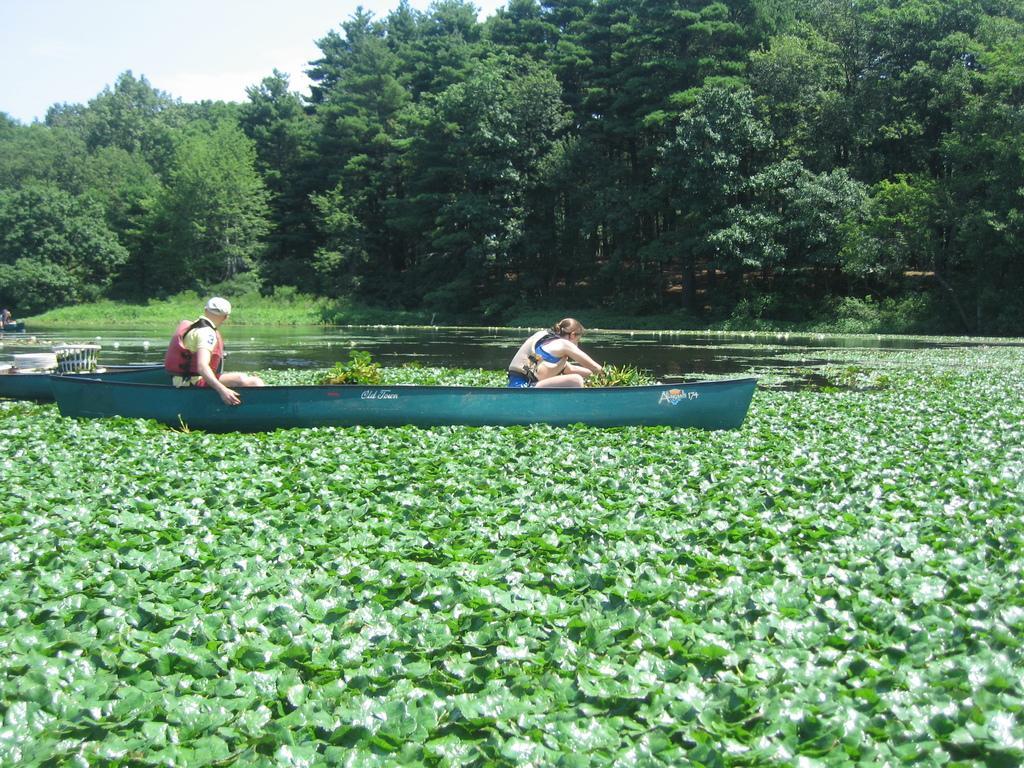Describe this image in one or two sentences. In this image I can see the boat on the water. I can see two people sitting on the boat. I can also see the green color leaves on the water. In the background there are many trees and the sky. 